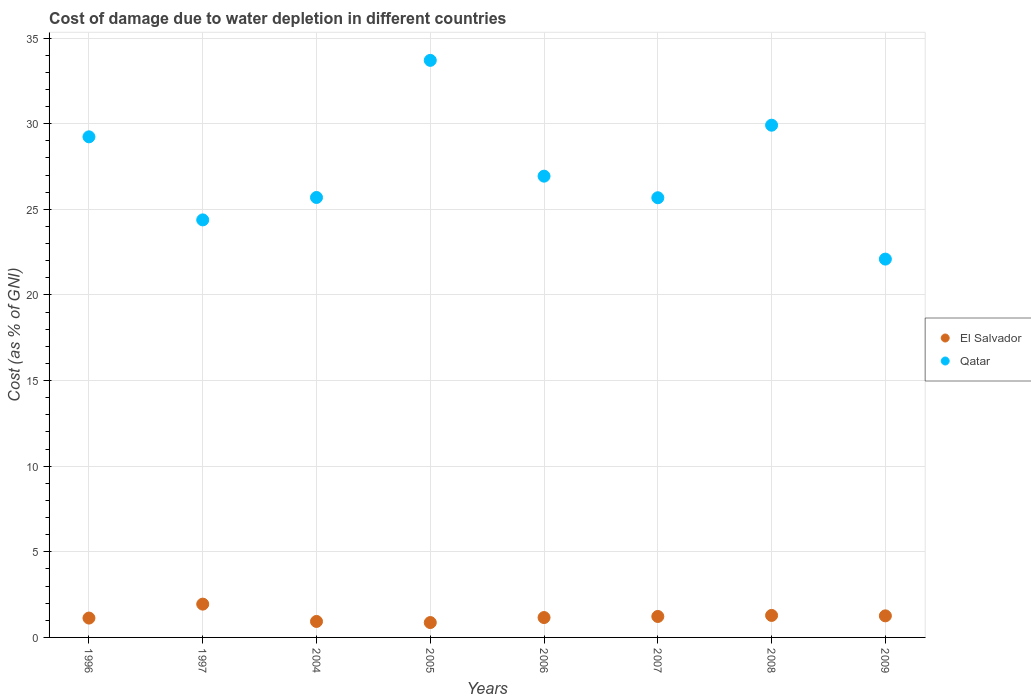How many different coloured dotlines are there?
Ensure brevity in your answer.  2. Is the number of dotlines equal to the number of legend labels?
Your answer should be very brief. Yes. What is the cost of damage caused due to water depletion in El Salvador in 2004?
Provide a short and direct response. 0.93. Across all years, what is the maximum cost of damage caused due to water depletion in El Salvador?
Provide a succinct answer. 1.94. Across all years, what is the minimum cost of damage caused due to water depletion in Qatar?
Keep it short and to the point. 22.09. In which year was the cost of damage caused due to water depletion in Qatar minimum?
Ensure brevity in your answer.  2009. What is the total cost of damage caused due to water depletion in El Salvador in the graph?
Make the answer very short. 9.81. What is the difference between the cost of damage caused due to water depletion in Qatar in 2007 and that in 2008?
Your response must be concise. -4.24. What is the difference between the cost of damage caused due to water depletion in Qatar in 1997 and the cost of damage caused due to water depletion in El Salvador in 2009?
Make the answer very short. 23.12. What is the average cost of damage caused due to water depletion in El Salvador per year?
Provide a short and direct response. 1.23. In the year 2008, what is the difference between the cost of damage caused due to water depletion in Qatar and cost of damage caused due to water depletion in El Salvador?
Make the answer very short. 28.63. In how many years, is the cost of damage caused due to water depletion in Qatar greater than 29 %?
Your response must be concise. 3. What is the ratio of the cost of damage caused due to water depletion in El Salvador in 2005 to that in 2009?
Offer a terse response. 0.69. Is the cost of damage caused due to water depletion in Qatar in 2007 less than that in 2009?
Your answer should be compact. No. What is the difference between the highest and the second highest cost of damage caused due to water depletion in Qatar?
Make the answer very short. 3.79. What is the difference between the highest and the lowest cost of damage caused due to water depletion in El Salvador?
Your response must be concise. 1.08. Is the sum of the cost of damage caused due to water depletion in Qatar in 2005 and 2008 greater than the maximum cost of damage caused due to water depletion in El Salvador across all years?
Give a very brief answer. Yes. Does the cost of damage caused due to water depletion in Qatar monotonically increase over the years?
Your answer should be compact. No. Is the cost of damage caused due to water depletion in Qatar strictly greater than the cost of damage caused due to water depletion in El Salvador over the years?
Offer a terse response. Yes. Is the cost of damage caused due to water depletion in El Salvador strictly less than the cost of damage caused due to water depletion in Qatar over the years?
Your response must be concise. Yes. How many years are there in the graph?
Keep it short and to the point. 8. Does the graph contain grids?
Your response must be concise. Yes. Where does the legend appear in the graph?
Give a very brief answer. Center right. How many legend labels are there?
Ensure brevity in your answer.  2. What is the title of the graph?
Offer a terse response. Cost of damage due to water depletion in different countries. Does "Barbados" appear as one of the legend labels in the graph?
Offer a terse response. No. What is the label or title of the Y-axis?
Offer a terse response. Cost (as % of GNI). What is the Cost (as % of GNI) in El Salvador in 1996?
Give a very brief answer. 1.13. What is the Cost (as % of GNI) of Qatar in 1996?
Provide a succinct answer. 29.23. What is the Cost (as % of GNI) of El Salvador in 1997?
Your response must be concise. 1.94. What is the Cost (as % of GNI) in Qatar in 1997?
Provide a succinct answer. 24.38. What is the Cost (as % of GNI) of El Salvador in 2004?
Ensure brevity in your answer.  0.93. What is the Cost (as % of GNI) in Qatar in 2004?
Offer a very short reply. 25.69. What is the Cost (as % of GNI) of El Salvador in 2005?
Provide a succinct answer. 0.87. What is the Cost (as % of GNI) in Qatar in 2005?
Your response must be concise. 33.7. What is the Cost (as % of GNI) of El Salvador in 2006?
Make the answer very short. 1.16. What is the Cost (as % of GNI) of Qatar in 2006?
Your answer should be compact. 26.94. What is the Cost (as % of GNI) of El Salvador in 2007?
Your answer should be very brief. 1.22. What is the Cost (as % of GNI) in Qatar in 2007?
Ensure brevity in your answer.  25.67. What is the Cost (as % of GNI) in El Salvador in 2008?
Your answer should be compact. 1.28. What is the Cost (as % of GNI) of Qatar in 2008?
Give a very brief answer. 29.91. What is the Cost (as % of GNI) of El Salvador in 2009?
Provide a succinct answer. 1.26. What is the Cost (as % of GNI) in Qatar in 2009?
Your response must be concise. 22.09. Across all years, what is the maximum Cost (as % of GNI) in El Salvador?
Your answer should be very brief. 1.94. Across all years, what is the maximum Cost (as % of GNI) in Qatar?
Ensure brevity in your answer.  33.7. Across all years, what is the minimum Cost (as % of GNI) of El Salvador?
Provide a short and direct response. 0.87. Across all years, what is the minimum Cost (as % of GNI) in Qatar?
Keep it short and to the point. 22.09. What is the total Cost (as % of GNI) of El Salvador in the graph?
Provide a short and direct response. 9.81. What is the total Cost (as % of GNI) in Qatar in the graph?
Your response must be concise. 217.61. What is the difference between the Cost (as % of GNI) in El Salvador in 1996 and that in 1997?
Your answer should be compact. -0.81. What is the difference between the Cost (as % of GNI) in Qatar in 1996 and that in 1997?
Offer a very short reply. 4.85. What is the difference between the Cost (as % of GNI) in El Salvador in 1996 and that in 2004?
Offer a terse response. 0.2. What is the difference between the Cost (as % of GNI) of Qatar in 1996 and that in 2004?
Give a very brief answer. 3.54. What is the difference between the Cost (as % of GNI) in El Salvador in 1996 and that in 2005?
Keep it short and to the point. 0.26. What is the difference between the Cost (as % of GNI) in Qatar in 1996 and that in 2005?
Provide a succinct answer. -4.47. What is the difference between the Cost (as % of GNI) in El Salvador in 1996 and that in 2006?
Offer a very short reply. -0.03. What is the difference between the Cost (as % of GNI) of Qatar in 1996 and that in 2006?
Ensure brevity in your answer.  2.3. What is the difference between the Cost (as % of GNI) in El Salvador in 1996 and that in 2007?
Give a very brief answer. -0.09. What is the difference between the Cost (as % of GNI) of Qatar in 1996 and that in 2007?
Keep it short and to the point. 3.56. What is the difference between the Cost (as % of GNI) of El Salvador in 1996 and that in 2008?
Provide a succinct answer. -0.15. What is the difference between the Cost (as % of GNI) of Qatar in 1996 and that in 2008?
Ensure brevity in your answer.  -0.68. What is the difference between the Cost (as % of GNI) in El Salvador in 1996 and that in 2009?
Provide a short and direct response. -0.13. What is the difference between the Cost (as % of GNI) in Qatar in 1996 and that in 2009?
Provide a short and direct response. 7.14. What is the difference between the Cost (as % of GNI) of El Salvador in 1997 and that in 2004?
Your answer should be compact. 1.01. What is the difference between the Cost (as % of GNI) in Qatar in 1997 and that in 2004?
Give a very brief answer. -1.31. What is the difference between the Cost (as % of GNI) in El Salvador in 1997 and that in 2005?
Offer a very short reply. 1.08. What is the difference between the Cost (as % of GNI) in Qatar in 1997 and that in 2005?
Provide a succinct answer. -9.32. What is the difference between the Cost (as % of GNI) of El Salvador in 1997 and that in 2006?
Offer a very short reply. 0.78. What is the difference between the Cost (as % of GNI) in Qatar in 1997 and that in 2006?
Your answer should be compact. -2.55. What is the difference between the Cost (as % of GNI) of El Salvador in 1997 and that in 2007?
Your response must be concise. 0.72. What is the difference between the Cost (as % of GNI) of Qatar in 1997 and that in 2007?
Your response must be concise. -1.29. What is the difference between the Cost (as % of GNI) of El Salvador in 1997 and that in 2008?
Your response must be concise. 0.66. What is the difference between the Cost (as % of GNI) in Qatar in 1997 and that in 2008?
Provide a short and direct response. -5.53. What is the difference between the Cost (as % of GNI) in El Salvador in 1997 and that in 2009?
Provide a short and direct response. 0.68. What is the difference between the Cost (as % of GNI) in Qatar in 1997 and that in 2009?
Offer a terse response. 2.29. What is the difference between the Cost (as % of GNI) in El Salvador in 2004 and that in 2005?
Give a very brief answer. 0.06. What is the difference between the Cost (as % of GNI) of Qatar in 2004 and that in 2005?
Offer a terse response. -8.01. What is the difference between the Cost (as % of GNI) in El Salvador in 2004 and that in 2006?
Your response must be concise. -0.23. What is the difference between the Cost (as % of GNI) of Qatar in 2004 and that in 2006?
Ensure brevity in your answer.  -1.24. What is the difference between the Cost (as % of GNI) of El Salvador in 2004 and that in 2007?
Make the answer very short. -0.29. What is the difference between the Cost (as % of GNI) of Qatar in 2004 and that in 2007?
Offer a terse response. 0.02. What is the difference between the Cost (as % of GNI) of El Salvador in 2004 and that in 2008?
Offer a terse response. -0.35. What is the difference between the Cost (as % of GNI) of Qatar in 2004 and that in 2008?
Give a very brief answer. -4.22. What is the difference between the Cost (as % of GNI) of El Salvador in 2004 and that in 2009?
Your response must be concise. -0.33. What is the difference between the Cost (as % of GNI) in Qatar in 2004 and that in 2009?
Make the answer very short. 3.6. What is the difference between the Cost (as % of GNI) of El Salvador in 2005 and that in 2006?
Your answer should be compact. -0.29. What is the difference between the Cost (as % of GNI) in Qatar in 2005 and that in 2006?
Provide a short and direct response. 6.76. What is the difference between the Cost (as % of GNI) of El Salvador in 2005 and that in 2007?
Provide a succinct answer. -0.36. What is the difference between the Cost (as % of GNI) of Qatar in 2005 and that in 2007?
Ensure brevity in your answer.  8.02. What is the difference between the Cost (as % of GNI) of El Salvador in 2005 and that in 2008?
Make the answer very short. -0.42. What is the difference between the Cost (as % of GNI) in Qatar in 2005 and that in 2008?
Ensure brevity in your answer.  3.79. What is the difference between the Cost (as % of GNI) in El Salvador in 2005 and that in 2009?
Provide a short and direct response. -0.39. What is the difference between the Cost (as % of GNI) of Qatar in 2005 and that in 2009?
Offer a terse response. 11.61. What is the difference between the Cost (as % of GNI) of El Salvador in 2006 and that in 2007?
Provide a succinct answer. -0.06. What is the difference between the Cost (as % of GNI) in Qatar in 2006 and that in 2007?
Offer a terse response. 1.26. What is the difference between the Cost (as % of GNI) of El Salvador in 2006 and that in 2008?
Offer a very short reply. -0.12. What is the difference between the Cost (as % of GNI) of Qatar in 2006 and that in 2008?
Offer a terse response. -2.98. What is the difference between the Cost (as % of GNI) in El Salvador in 2006 and that in 2009?
Offer a terse response. -0.1. What is the difference between the Cost (as % of GNI) in Qatar in 2006 and that in 2009?
Provide a succinct answer. 4.84. What is the difference between the Cost (as % of GNI) of El Salvador in 2007 and that in 2008?
Provide a short and direct response. -0.06. What is the difference between the Cost (as % of GNI) in Qatar in 2007 and that in 2008?
Your answer should be compact. -4.24. What is the difference between the Cost (as % of GNI) of El Salvador in 2007 and that in 2009?
Provide a short and direct response. -0.04. What is the difference between the Cost (as % of GNI) of Qatar in 2007 and that in 2009?
Ensure brevity in your answer.  3.58. What is the difference between the Cost (as % of GNI) of El Salvador in 2008 and that in 2009?
Your response must be concise. 0.02. What is the difference between the Cost (as % of GNI) in Qatar in 2008 and that in 2009?
Your answer should be compact. 7.82. What is the difference between the Cost (as % of GNI) of El Salvador in 1996 and the Cost (as % of GNI) of Qatar in 1997?
Ensure brevity in your answer.  -23.25. What is the difference between the Cost (as % of GNI) of El Salvador in 1996 and the Cost (as % of GNI) of Qatar in 2004?
Make the answer very short. -24.56. What is the difference between the Cost (as % of GNI) in El Salvador in 1996 and the Cost (as % of GNI) in Qatar in 2005?
Your answer should be very brief. -32.57. What is the difference between the Cost (as % of GNI) in El Salvador in 1996 and the Cost (as % of GNI) in Qatar in 2006?
Your answer should be very brief. -25.8. What is the difference between the Cost (as % of GNI) in El Salvador in 1996 and the Cost (as % of GNI) in Qatar in 2007?
Provide a succinct answer. -24.54. What is the difference between the Cost (as % of GNI) in El Salvador in 1996 and the Cost (as % of GNI) in Qatar in 2008?
Keep it short and to the point. -28.78. What is the difference between the Cost (as % of GNI) in El Salvador in 1996 and the Cost (as % of GNI) in Qatar in 2009?
Offer a very short reply. -20.96. What is the difference between the Cost (as % of GNI) of El Salvador in 1997 and the Cost (as % of GNI) of Qatar in 2004?
Provide a short and direct response. -23.75. What is the difference between the Cost (as % of GNI) in El Salvador in 1997 and the Cost (as % of GNI) in Qatar in 2005?
Offer a very short reply. -31.75. What is the difference between the Cost (as % of GNI) of El Salvador in 1997 and the Cost (as % of GNI) of Qatar in 2006?
Give a very brief answer. -24.99. What is the difference between the Cost (as % of GNI) in El Salvador in 1997 and the Cost (as % of GNI) in Qatar in 2007?
Ensure brevity in your answer.  -23.73. What is the difference between the Cost (as % of GNI) of El Salvador in 1997 and the Cost (as % of GNI) of Qatar in 2008?
Offer a very short reply. -27.97. What is the difference between the Cost (as % of GNI) in El Salvador in 1997 and the Cost (as % of GNI) in Qatar in 2009?
Your response must be concise. -20.15. What is the difference between the Cost (as % of GNI) of El Salvador in 2004 and the Cost (as % of GNI) of Qatar in 2005?
Ensure brevity in your answer.  -32.76. What is the difference between the Cost (as % of GNI) in El Salvador in 2004 and the Cost (as % of GNI) in Qatar in 2006?
Your response must be concise. -26. What is the difference between the Cost (as % of GNI) of El Salvador in 2004 and the Cost (as % of GNI) of Qatar in 2007?
Your response must be concise. -24.74. What is the difference between the Cost (as % of GNI) in El Salvador in 2004 and the Cost (as % of GNI) in Qatar in 2008?
Keep it short and to the point. -28.98. What is the difference between the Cost (as % of GNI) of El Salvador in 2004 and the Cost (as % of GNI) of Qatar in 2009?
Make the answer very short. -21.16. What is the difference between the Cost (as % of GNI) of El Salvador in 2005 and the Cost (as % of GNI) of Qatar in 2006?
Your response must be concise. -26.07. What is the difference between the Cost (as % of GNI) of El Salvador in 2005 and the Cost (as % of GNI) of Qatar in 2007?
Your answer should be compact. -24.81. What is the difference between the Cost (as % of GNI) in El Salvador in 2005 and the Cost (as % of GNI) in Qatar in 2008?
Give a very brief answer. -29.04. What is the difference between the Cost (as % of GNI) in El Salvador in 2005 and the Cost (as % of GNI) in Qatar in 2009?
Keep it short and to the point. -21.22. What is the difference between the Cost (as % of GNI) of El Salvador in 2006 and the Cost (as % of GNI) of Qatar in 2007?
Ensure brevity in your answer.  -24.51. What is the difference between the Cost (as % of GNI) of El Salvador in 2006 and the Cost (as % of GNI) of Qatar in 2008?
Make the answer very short. -28.75. What is the difference between the Cost (as % of GNI) in El Salvador in 2006 and the Cost (as % of GNI) in Qatar in 2009?
Provide a short and direct response. -20.93. What is the difference between the Cost (as % of GNI) of El Salvador in 2007 and the Cost (as % of GNI) of Qatar in 2008?
Your answer should be very brief. -28.69. What is the difference between the Cost (as % of GNI) of El Salvador in 2007 and the Cost (as % of GNI) of Qatar in 2009?
Ensure brevity in your answer.  -20.87. What is the difference between the Cost (as % of GNI) in El Salvador in 2008 and the Cost (as % of GNI) in Qatar in 2009?
Provide a short and direct response. -20.81. What is the average Cost (as % of GNI) in El Salvador per year?
Provide a succinct answer. 1.23. What is the average Cost (as % of GNI) in Qatar per year?
Provide a short and direct response. 27.2. In the year 1996, what is the difference between the Cost (as % of GNI) of El Salvador and Cost (as % of GNI) of Qatar?
Offer a very short reply. -28.1. In the year 1997, what is the difference between the Cost (as % of GNI) of El Salvador and Cost (as % of GNI) of Qatar?
Offer a very short reply. -22.44. In the year 2004, what is the difference between the Cost (as % of GNI) of El Salvador and Cost (as % of GNI) of Qatar?
Offer a very short reply. -24.76. In the year 2005, what is the difference between the Cost (as % of GNI) of El Salvador and Cost (as % of GNI) of Qatar?
Provide a succinct answer. -32.83. In the year 2006, what is the difference between the Cost (as % of GNI) of El Salvador and Cost (as % of GNI) of Qatar?
Your answer should be very brief. -25.77. In the year 2007, what is the difference between the Cost (as % of GNI) of El Salvador and Cost (as % of GNI) of Qatar?
Offer a very short reply. -24.45. In the year 2008, what is the difference between the Cost (as % of GNI) of El Salvador and Cost (as % of GNI) of Qatar?
Your response must be concise. -28.63. In the year 2009, what is the difference between the Cost (as % of GNI) in El Salvador and Cost (as % of GNI) in Qatar?
Make the answer very short. -20.83. What is the ratio of the Cost (as % of GNI) in El Salvador in 1996 to that in 1997?
Provide a short and direct response. 0.58. What is the ratio of the Cost (as % of GNI) of Qatar in 1996 to that in 1997?
Keep it short and to the point. 1.2. What is the ratio of the Cost (as % of GNI) of El Salvador in 1996 to that in 2004?
Offer a very short reply. 1.21. What is the ratio of the Cost (as % of GNI) of Qatar in 1996 to that in 2004?
Offer a terse response. 1.14. What is the ratio of the Cost (as % of GNI) in El Salvador in 1996 to that in 2005?
Give a very brief answer. 1.3. What is the ratio of the Cost (as % of GNI) of Qatar in 1996 to that in 2005?
Your answer should be compact. 0.87. What is the ratio of the Cost (as % of GNI) of El Salvador in 1996 to that in 2006?
Ensure brevity in your answer.  0.97. What is the ratio of the Cost (as % of GNI) in Qatar in 1996 to that in 2006?
Provide a succinct answer. 1.09. What is the ratio of the Cost (as % of GNI) of El Salvador in 1996 to that in 2007?
Provide a short and direct response. 0.92. What is the ratio of the Cost (as % of GNI) of Qatar in 1996 to that in 2007?
Provide a succinct answer. 1.14. What is the ratio of the Cost (as % of GNI) in El Salvador in 1996 to that in 2008?
Provide a short and direct response. 0.88. What is the ratio of the Cost (as % of GNI) in Qatar in 1996 to that in 2008?
Make the answer very short. 0.98. What is the ratio of the Cost (as % of GNI) of El Salvador in 1996 to that in 2009?
Offer a very short reply. 0.9. What is the ratio of the Cost (as % of GNI) in Qatar in 1996 to that in 2009?
Offer a terse response. 1.32. What is the ratio of the Cost (as % of GNI) of El Salvador in 1997 to that in 2004?
Provide a succinct answer. 2.08. What is the ratio of the Cost (as % of GNI) of Qatar in 1997 to that in 2004?
Your response must be concise. 0.95. What is the ratio of the Cost (as % of GNI) in El Salvador in 1997 to that in 2005?
Offer a very short reply. 2.24. What is the ratio of the Cost (as % of GNI) of Qatar in 1997 to that in 2005?
Give a very brief answer. 0.72. What is the ratio of the Cost (as % of GNI) in El Salvador in 1997 to that in 2006?
Ensure brevity in your answer.  1.68. What is the ratio of the Cost (as % of GNI) of Qatar in 1997 to that in 2006?
Offer a terse response. 0.91. What is the ratio of the Cost (as % of GNI) of El Salvador in 1997 to that in 2007?
Your answer should be compact. 1.59. What is the ratio of the Cost (as % of GNI) in Qatar in 1997 to that in 2007?
Provide a succinct answer. 0.95. What is the ratio of the Cost (as % of GNI) in El Salvador in 1997 to that in 2008?
Your response must be concise. 1.51. What is the ratio of the Cost (as % of GNI) in Qatar in 1997 to that in 2008?
Your response must be concise. 0.82. What is the ratio of the Cost (as % of GNI) of El Salvador in 1997 to that in 2009?
Make the answer very short. 1.54. What is the ratio of the Cost (as % of GNI) in Qatar in 1997 to that in 2009?
Your answer should be compact. 1.1. What is the ratio of the Cost (as % of GNI) in El Salvador in 2004 to that in 2005?
Offer a terse response. 1.07. What is the ratio of the Cost (as % of GNI) in Qatar in 2004 to that in 2005?
Your answer should be compact. 0.76. What is the ratio of the Cost (as % of GNI) of El Salvador in 2004 to that in 2006?
Keep it short and to the point. 0.8. What is the ratio of the Cost (as % of GNI) of Qatar in 2004 to that in 2006?
Keep it short and to the point. 0.95. What is the ratio of the Cost (as % of GNI) of El Salvador in 2004 to that in 2007?
Make the answer very short. 0.76. What is the ratio of the Cost (as % of GNI) of Qatar in 2004 to that in 2007?
Give a very brief answer. 1. What is the ratio of the Cost (as % of GNI) in El Salvador in 2004 to that in 2008?
Keep it short and to the point. 0.73. What is the ratio of the Cost (as % of GNI) in Qatar in 2004 to that in 2008?
Your answer should be very brief. 0.86. What is the ratio of the Cost (as % of GNI) of El Salvador in 2004 to that in 2009?
Keep it short and to the point. 0.74. What is the ratio of the Cost (as % of GNI) of Qatar in 2004 to that in 2009?
Your answer should be very brief. 1.16. What is the ratio of the Cost (as % of GNI) in El Salvador in 2005 to that in 2006?
Offer a very short reply. 0.75. What is the ratio of the Cost (as % of GNI) in Qatar in 2005 to that in 2006?
Provide a short and direct response. 1.25. What is the ratio of the Cost (as % of GNI) of El Salvador in 2005 to that in 2007?
Keep it short and to the point. 0.71. What is the ratio of the Cost (as % of GNI) of Qatar in 2005 to that in 2007?
Keep it short and to the point. 1.31. What is the ratio of the Cost (as % of GNI) of El Salvador in 2005 to that in 2008?
Provide a short and direct response. 0.68. What is the ratio of the Cost (as % of GNI) of Qatar in 2005 to that in 2008?
Offer a very short reply. 1.13. What is the ratio of the Cost (as % of GNI) of El Salvador in 2005 to that in 2009?
Your answer should be very brief. 0.69. What is the ratio of the Cost (as % of GNI) in Qatar in 2005 to that in 2009?
Offer a very short reply. 1.53. What is the ratio of the Cost (as % of GNI) in El Salvador in 2006 to that in 2007?
Provide a short and direct response. 0.95. What is the ratio of the Cost (as % of GNI) in Qatar in 2006 to that in 2007?
Offer a very short reply. 1.05. What is the ratio of the Cost (as % of GNI) in El Salvador in 2006 to that in 2008?
Offer a terse response. 0.9. What is the ratio of the Cost (as % of GNI) of Qatar in 2006 to that in 2008?
Offer a very short reply. 0.9. What is the ratio of the Cost (as % of GNI) of El Salvador in 2006 to that in 2009?
Make the answer very short. 0.92. What is the ratio of the Cost (as % of GNI) in Qatar in 2006 to that in 2009?
Ensure brevity in your answer.  1.22. What is the ratio of the Cost (as % of GNI) in El Salvador in 2007 to that in 2008?
Your answer should be very brief. 0.95. What is the ratio of the Cost (as % of GNI) in Qatar in 2007 to that in 2008?
Your answer should be compact. 0.86. What is the ratio of the Cost (as % of GNI) in El Salvador in 2007 to that in 2009?
Your response must be concise. 0.97. What is the ratio of the Cost (as % of GNI) in Qatar in 2007 to that in 2009?
Provide a short and direct response. 1.16. What is the ratio of the Cost (as % of GNI) of El Salvador in 2008 to that in 2009?
Provide a succinct answer. 1.02. What is the ratio of the Cost (as % of GNI) of Qatar in 2008 to that in 2009?
Offer a terse response. 1.35. What is the difference between the highest and the second highest Cost (as % of GNI) in El Salvador?
Provide a succinct answer. 0.66. What is the difference between the highest and the second highest Cost (as % of GNI) of Qatar?
Provide a succinct answer. 3.79. What is the difference between the highest and the lowest Cost (as % of GNI) of El Salvador?
Your response must be concise. 1.08. What is the difference between the highest and the lowest Cost (as % of GNI) in Qatar?
Offer a terse response. 11.61. 